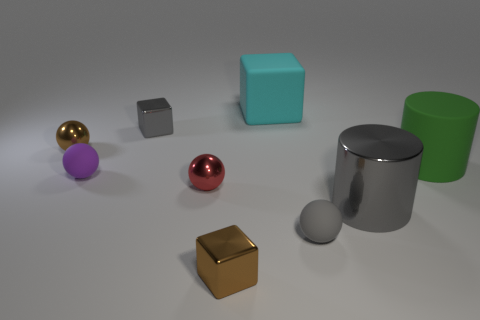Is there a red ball that has the same material as the tiny brown cube?
Your answer should be very brief. Yes. The other tiny matte object that is the same shape as the gray rubber object is what color?
Your answer should be very brief. Purple. Is the number of big green rubber cylinders on the left side of the gray shiny cylinder less than the number of brown metallic balls that are in front of the large block?
Keep it short and to the point. Yes. How many other things are there of the same shape as the green thing?
Provide a short and direct response. 1. Is the number of green matte cylinders in front of the large matte block less than the number of purple rubber balls?
Your answer should be compact. No. What material is the cube in front of the rubber cylinder?
Provide a succinct answer. Metal. How many other things are the same size as the gray metallic cylinder?
Your response must be concise. 2. Are there fewer red metallic balls than cyan shiny cylinders?
Provide a short and direct response. No. There is a large gray object; what shape is it?
Your response must be concise. Cylinder. There is a tiny object in front of the gray rubber thing; is it the same color as the rubber cube?
Ensure brevity in your answer.  No. 